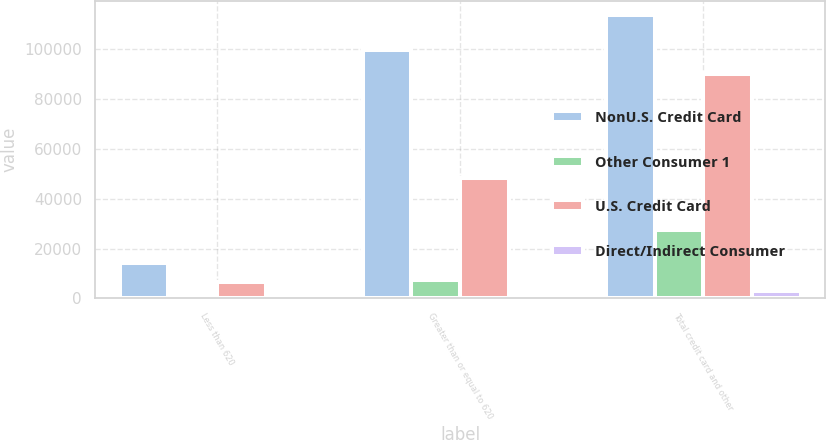Convert chart to OTSL. <chart><loc_0><loc_0><loc_500><loc_500><stacked_bar_chart><ecel><fcel>Less than 620<fcel>Greater than or equal to 620<fcel>Total credit card and other<nl><fcel>NonU.S. Credit Card<fcel>14159<fcel>99626<fcel>113785<nl><fcel>Other Consumer 1<fcel>631<fcel>7528<fcel>27465<nl><fcel>U.S. Credit Card<fcel>6748<fcel>48209<fcel>90308<nl><fcel>Direct/Indirect Consumer<fcel>979<fcel>961<fcel>2830<nl></chart> 